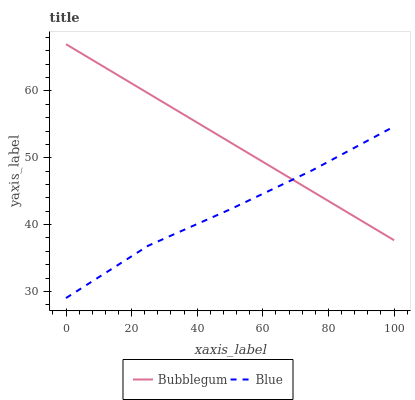Does Blue have the minimum area under the curve?
Answer yes or no. Yes. Does Bubblegum have the maximum area under the curve?
Answer yes or no. Yes. Does Bubblegum have the minimum area under the curve?
Answer yes or no. No. Is Bubblegum the smoothest?
Answer yes or no. Yes. Is Blue the roughest?
Answer yes or no. Yes. Is Bubblegum the roughest?
Answer yes or no. No. Does Bubblegum have the lowest value?
Answer yes or no. No. Does Bubblegum have the highest value?
Answer yes or no. Yes. Does Blue intersect Bubblegum?
Answer yes or no. Yes. Is Blue less than Bubblegum?
Answer yes or no. No. Is Blue greater than Bubblegum?
Answer yes or no. No. 